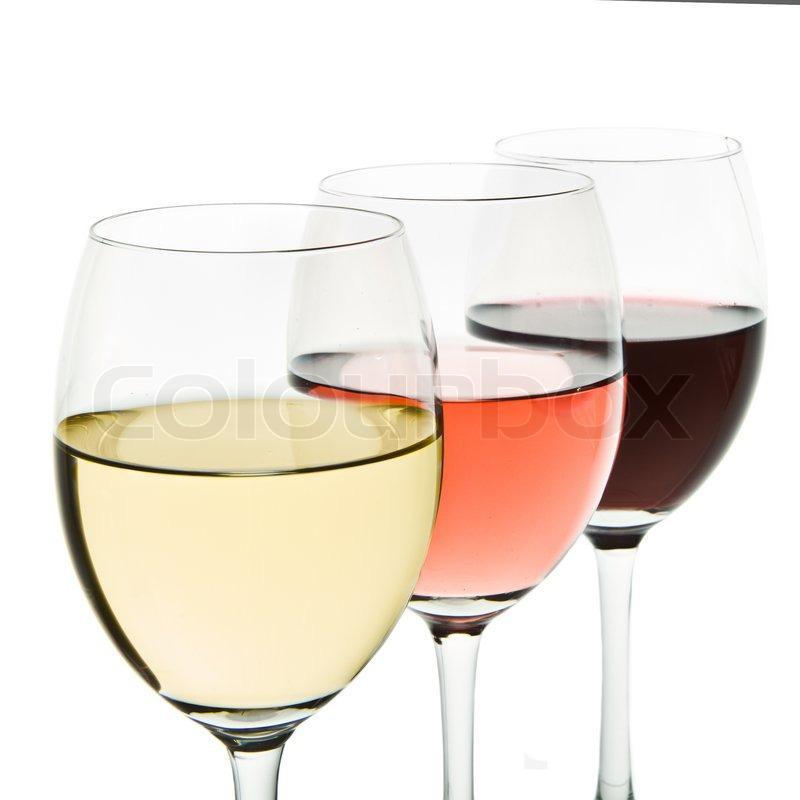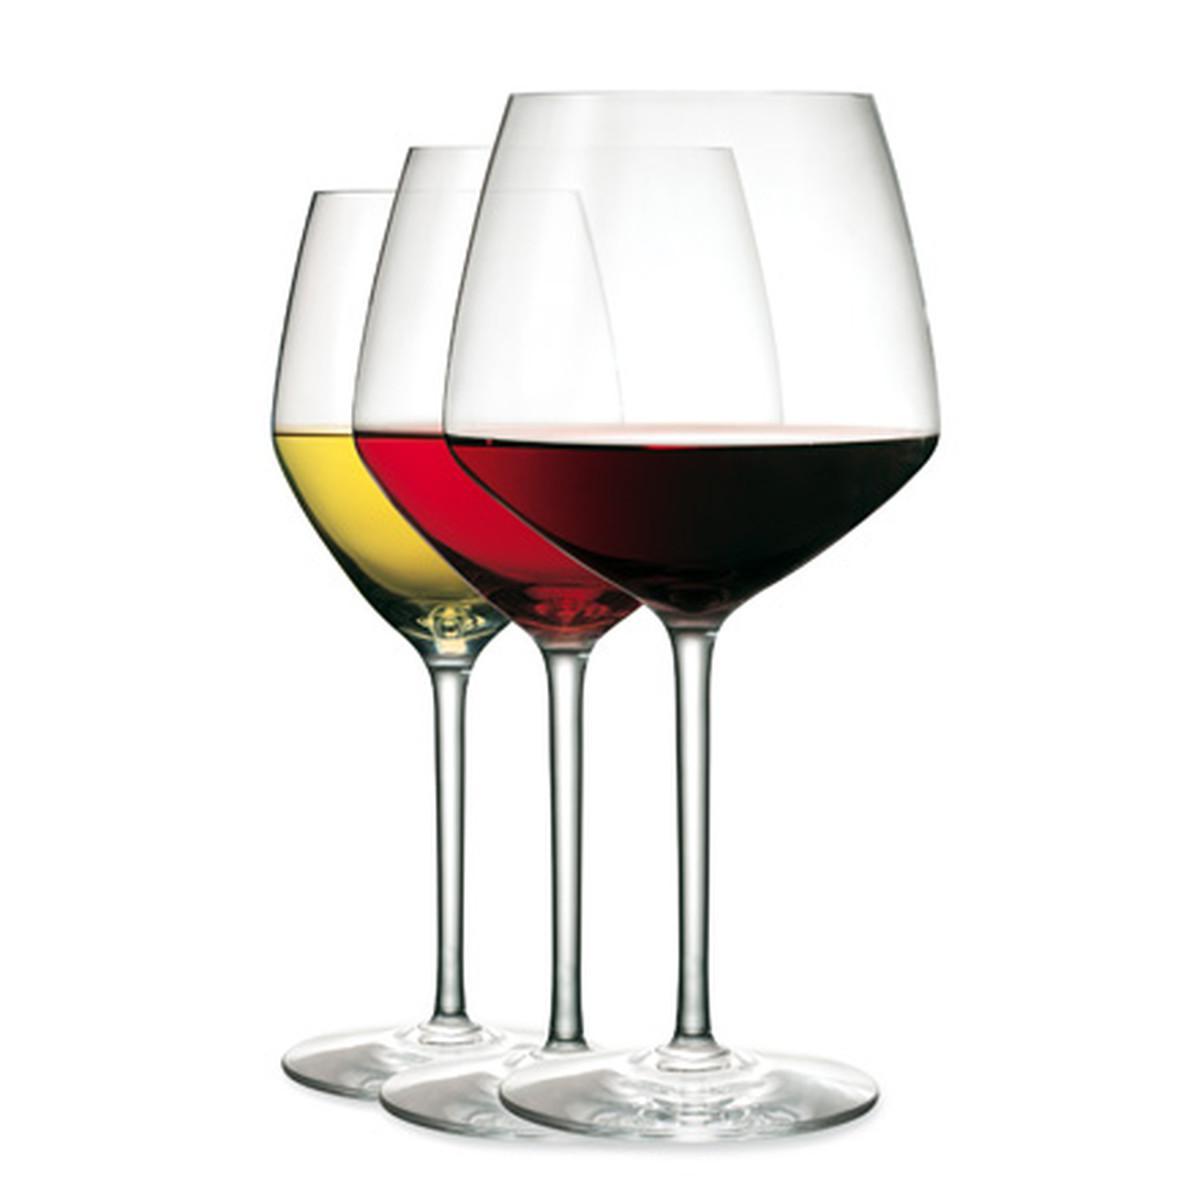The first image is the image on the left, the second image is the image on the right. Considering the images on both sides, is "There are four glasses of liquid in one of the images." valid? Answer yes or no. No. The first image is the image on the left, the second image is the image on the right. For the images shown, is this caption "One image contains four glasses of different colors of wine." true? Answer yes or no. No. 